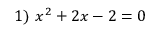Convert formula to latex. <formula><loc_0><loc_0><loc_500><loc_500>1 ) \ x ^ { 2 } + 2 x - 2 = 0</formula> 